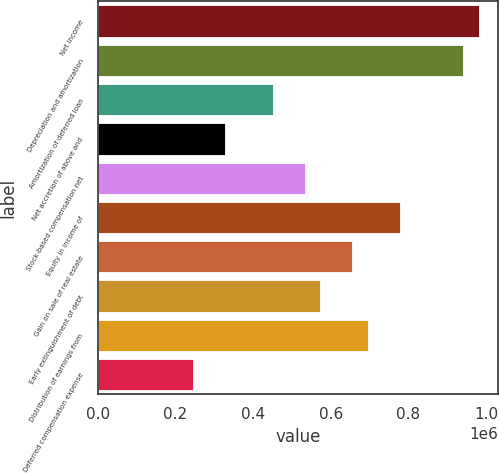Convert chart to OTSL. <chart><loc_0><loc_0><loc_500><loc_500><bar_chart><fcel>Net income<fcel>Depreciation and amortization<fcel>Amortization of deferred loan<fcel>Net accretion of above and<fcel>Stock-based compensation net<fcel>Equity in income of<fcel>Gain on sale of real estate<fcel>Early extinguishment of debt<fcel>Distribution of earnings from<fcel>Deferred compensation expense<nl><fcel>983128<fcel>942167<fcel>450632<fcel>327749<fcel>532555<fcel>778322<fcel>655438<fcel>573516<fcel>696399<fcel>245826<nl></chart> 